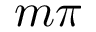<formula> <loc_0><loc_0><loc_500><loc_500>m \pi</formula> 